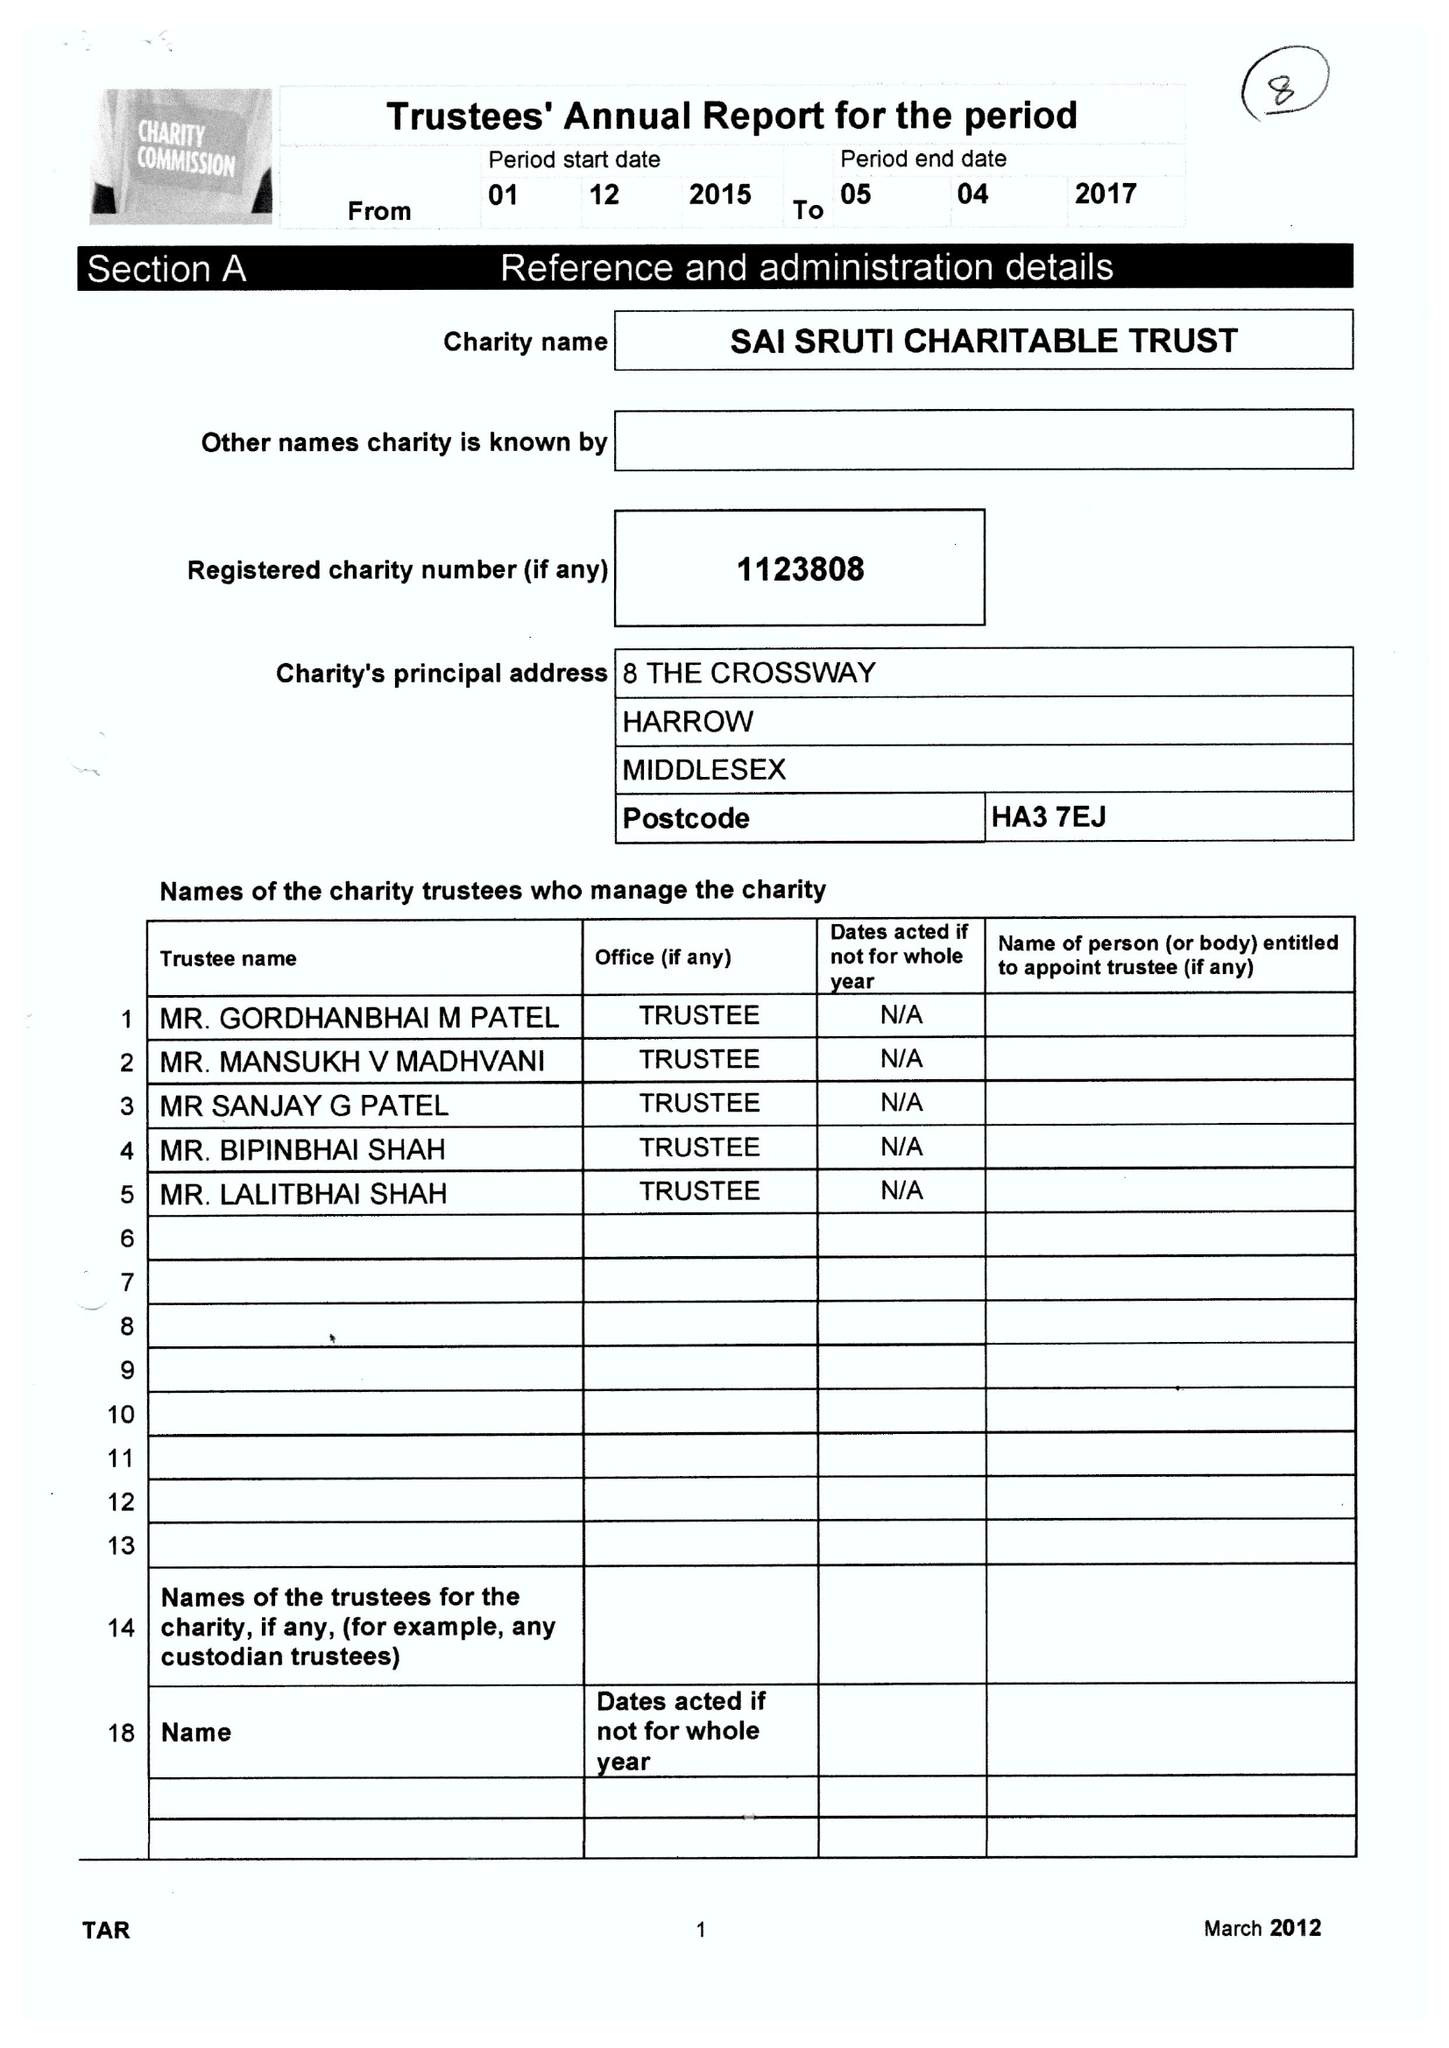What is the value for the address__street_line?
Answer the question using a single word or phrase. 8 THE CROSS WAY 